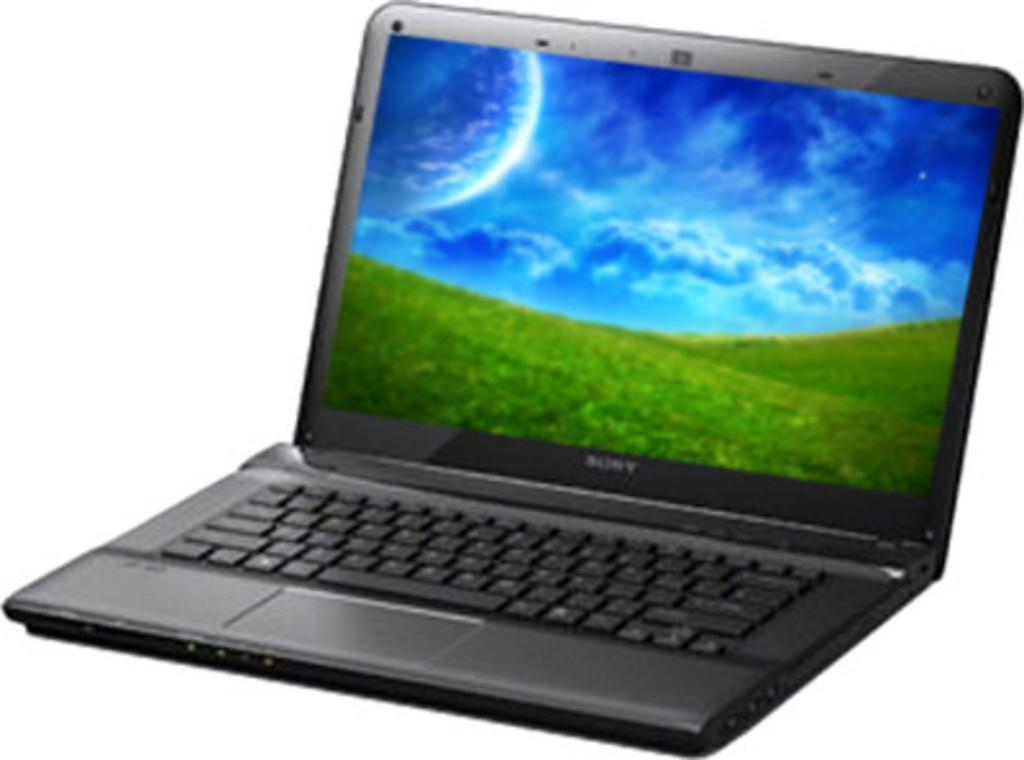<image>
Present a compact description of the photo's key features. a small black sony laptop with grass and the sky on the computer screen 